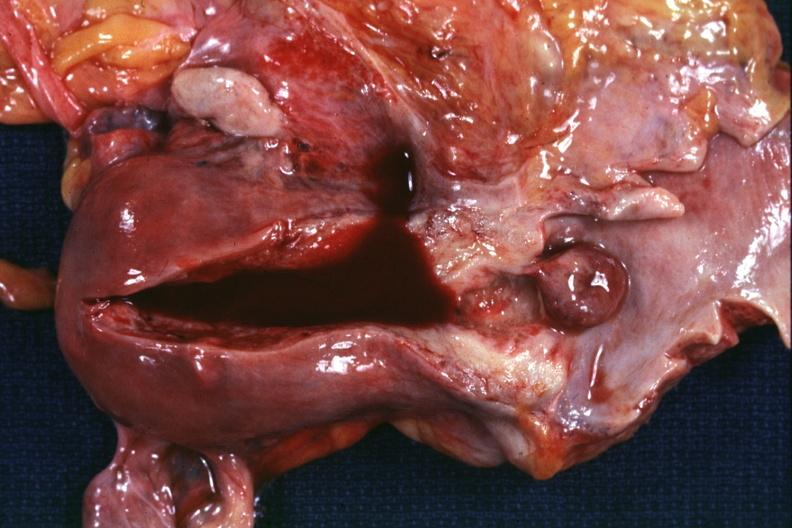what is present?
Answer the question using a single word or phrase. Female reproductive 